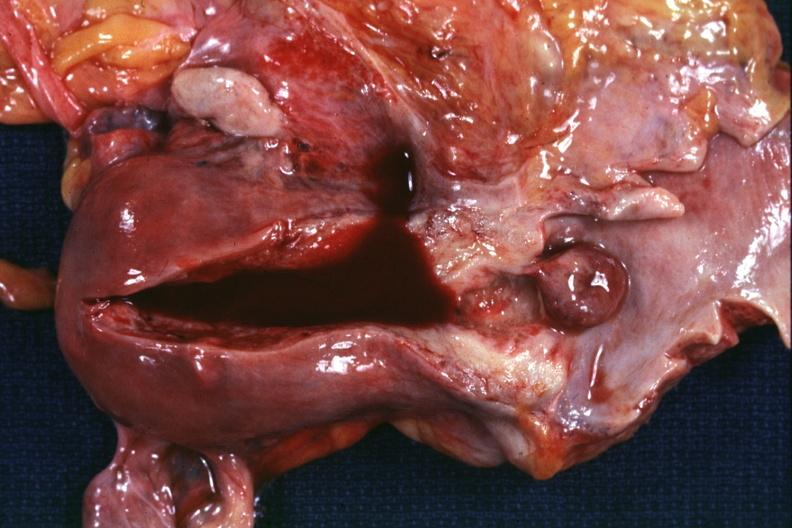what is present?
Answer the question using a single word or phrase. Female reproductive 